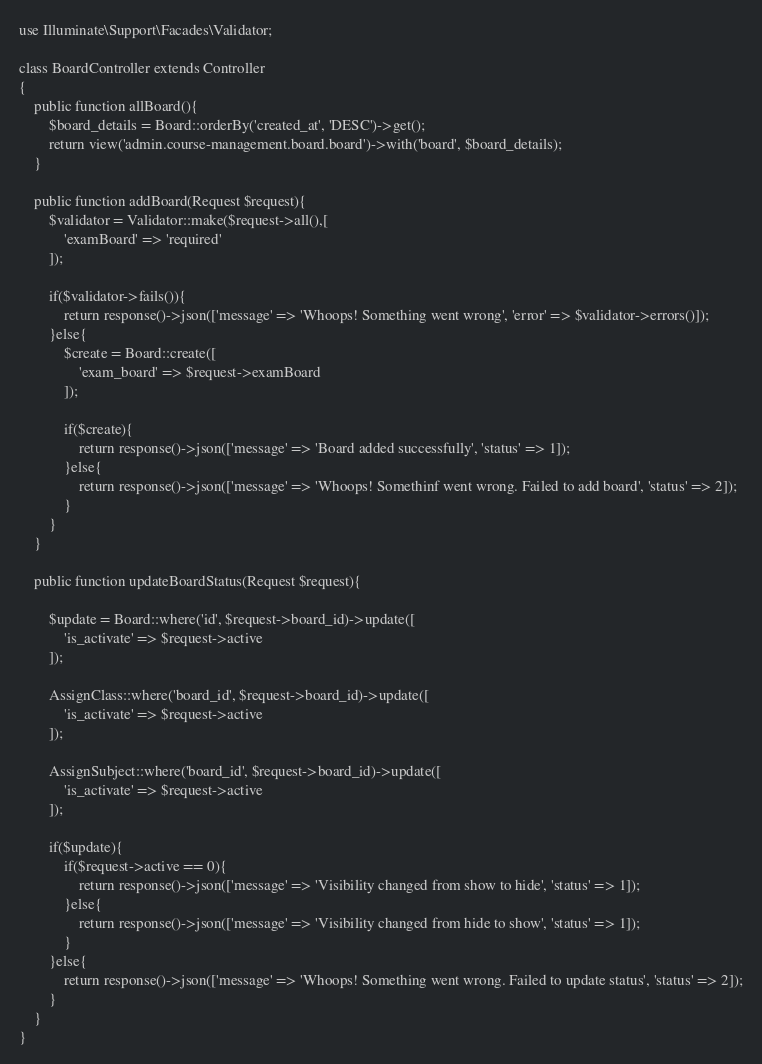Convert code to text. <code><loc_0><loc_0><loc_500><loc_500><_PHP_>use Illuminate\Support\Facades\Validator;

class BoardController extends Controller
{
    public function allBoard(){
        $board_details = Board::orderBy('created_at', 'DESC')->get();
        return view('admin.course-management.board.board')->with('board', $board_details);
    }

    public function addBoard(Request $request){
        $validator = Validator::make($request->all(),[
            'examBoard' => 'required'
        ]);

        if($validator->fails()){
            return response()->json(['message' => 'Whoops! Something went wrong', 'error' => $validator->errors()]);
        }else{
            $create = Board::create([
                'exam_board' => $request->examBoard
            ]);

            if($create){
                return response()->json(['message' => 'Board added successfully', 'status' => 1]);
            }else{
                return response()->json(['message' => 'Whoops! Somethinf went wrong. Failed to add board', 'status' => 2]);
            }
        }
    }

    public function updateBoardStatus(Request $request){
        
        $update = Board::where('id', $request->board_id)->update([
            'is_activate' => $request->active
        ]);

        AssignClass::where('board_id', $request->board_id)->update([
            'is_activate' => $request->active
        ]);

        AssignSubject::where('board_id', $request->board_id)->update([
            'is_activate' => $request->active
        ]);

        if($update){
            if($request->active == 0){
                return response()->json(['message' => 'Visibility changed from show to hide', 'status' => 1]);
            }else{
                return response()->json(['message' => 'Visibility changed from hide to show', 'status' => 1]);
            }
        }else{
            return response()->json(['message' => 'Whoops! Something went wrong. Failed to update status', 'status' => 2]);
        }
    }
}
</code> 